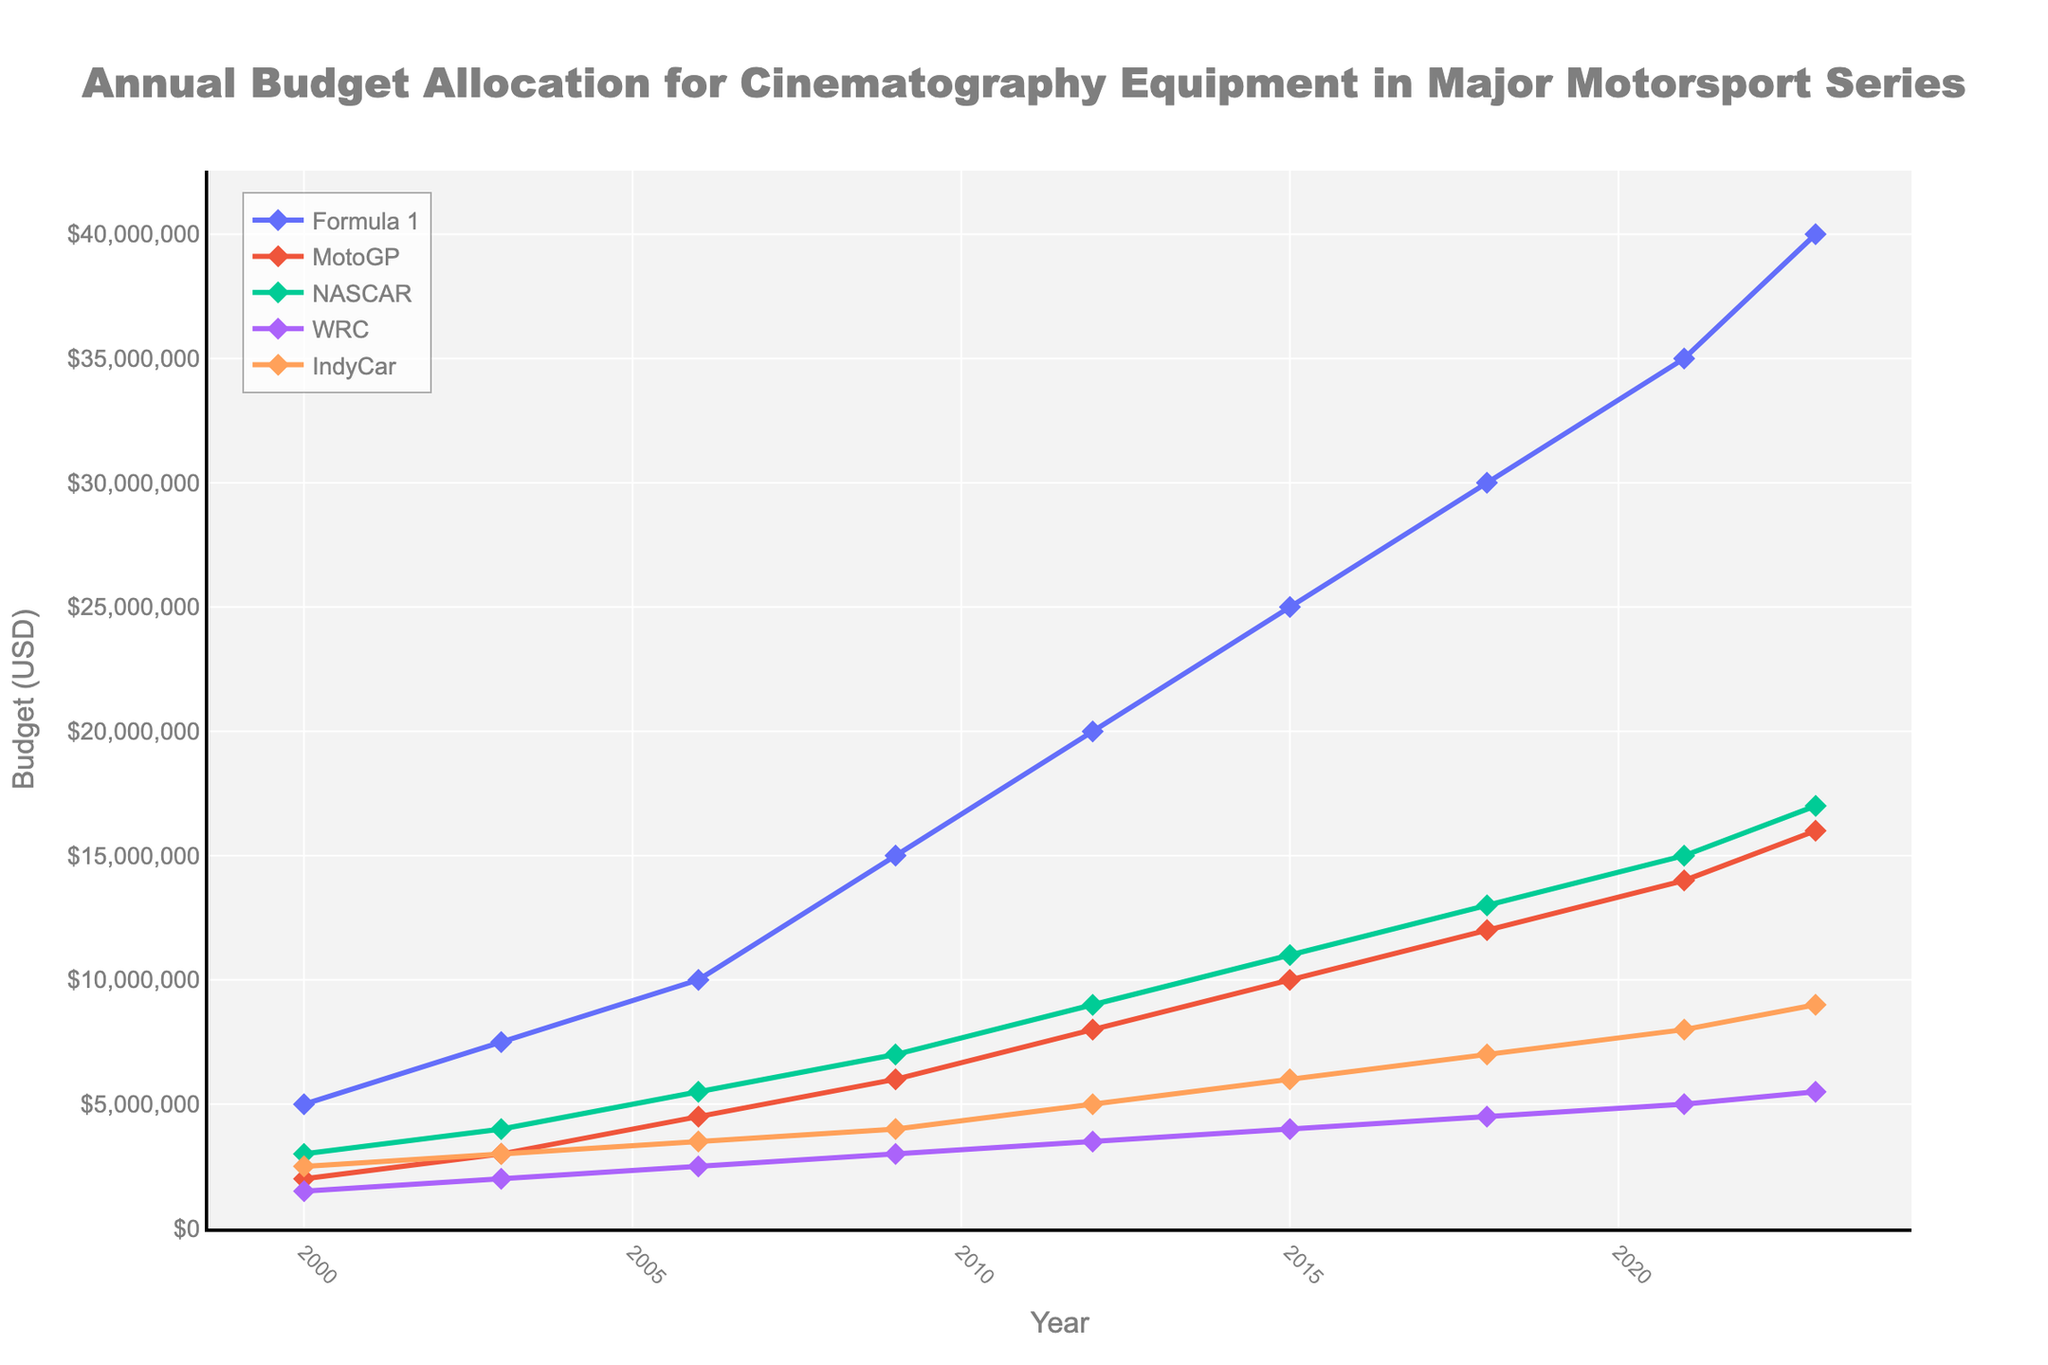Which motorsport series had the highest budget allocation in 2023? Look at the last data point for each series and identify the one with the highest value. Formula 1 has the highest budget allocation at $40,000,000.
Answer: Formula 1 How much did the budget allocation for cinematography equipment in NASCAR increase from 2000 to 2023? Subtract the 2000 value from the 2023 value for NASCAR. 17,000,000 - 3,000,000 = 14,000,000.
Answer: $14,000,000 What is the average budget allocation for WRC from 2000 to 2023? Sum the budget allocations for all given years for WRC and divide by the number of years provided. The total budget allocation is 35,000,000 and there are 9 years, so the average budget allocation is 35,000,000 / 9 ≈ 3,888,889.
Answer: $3,888,889 Between which two consecutive years did MotoGP see the largest increase in budget allocation? Calculate the differences between consecutive years and identify the largest one. The largest increase is between 2018 and 2021, going from $12,000,000 to $14,000,000, an increase of $2,000,000.
Answer: 2018 to 2021 Which motorsport series had the smallest budget allocation in 2012? Compare the budget allocations in 2012 for all series and identify the smallest one. WRC has the smallest budget allocation at $3,500,000.
Answer: WRC What is the total increase in budget allocation for Formula 1 from 2003 to 2023? Subtract the 2003 value from the 2023 value for Formula 1. 40,000,000 - 7,500,000 = 32,500,000.
Answer: $32,500,000 What is the difference in budget allocation between IndyCar and MotoGP in 2021? Subtract the MotoGP budget allocation from the IndyCar budget allocation for 2021. 8,000,000 - 14,000,000 = -6,000,000.
Answer: -$6,000,000 How much did the WRC budget allocation increase from 2000 to 2023 in percentage terms? Calculate the percentage increase using the formula [(final value - initial value) / initial value] * 100. [(5,500,000 - 1,500,000) / 1,500,000] * 100 = 266.67%.
Answer: 266.67% Which two series had the closest budget allocations in 2015? Compare the budget allocations for each pair of series in 2015 and identify the pair with the smallest difference. The closest budget allocations are between NASCAR and IndyCar, with values of 11,000,000 and 6,000,000, respectively. The difference is $5,000,000.
Answer: NASCAR and IndyCar Across the whole period, which motorsport series consistently had increasing budget allocations every year? Identify the series that shows a year-on-year increase for every data point. Formula 1 shows consistent year-on-year increases.
Answer: Formula 1 